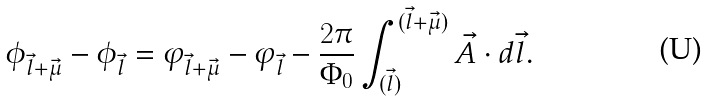<formula> <loc_0><loc_0><loc_500><loc_500>\phi _ { \vec { l } + \vec { \mu } } - \phi _ { \vec { l } } = \varphi _ { \vec { l } + \vec { \mu } } - \varphi _ { \vec { l } } - \frac { 2 \pi } { \Phi _ { 0 } } \int _ { ( \vec { l } ) } ^ { ( \vec { l } + \vec { \mu } ) } { \vec { A } \cdot d \vec { l } } .</formula> 